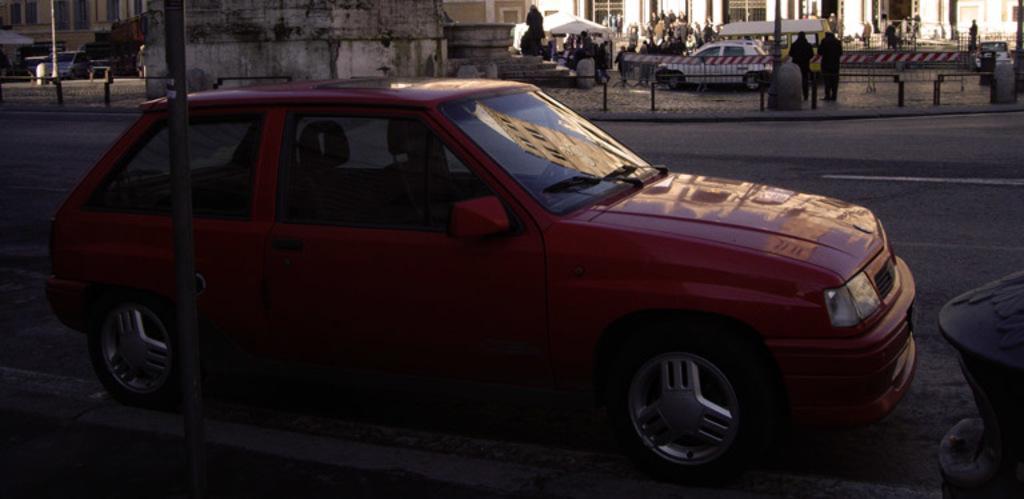Describe this image in one or two sentences. In this image, we can see vehicles on the road and in the background, there are people, buildings, railings, poles, stones, tents and there is a statue. 